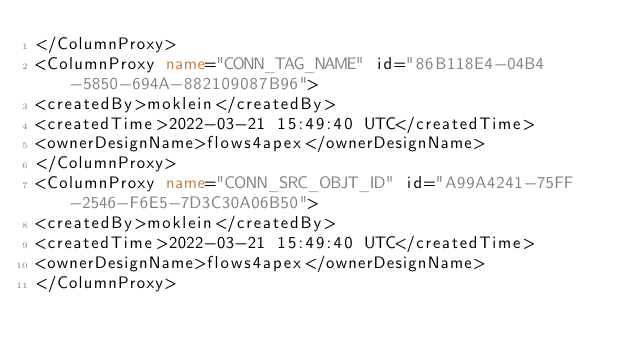Convert code to text. <code><loc_0><loc_0><loc_500><loc_500><_XML_></ColumnProxy>
<ColumnProxy name="CONN_TAG_NAME" id="86B118E4-04B4-5850-694A-882109087B96">
<createdBy>moklein</createdBy>
<createdTime>2022-03-21 15:49:40 UTC</createdTime>
<ownerDesignName>flows4apex</ownerDesignName>
</ColumnProxy>
<ColumnProxy name="CONN_SRC_OBJT_ID" id="A99A4241-75FF-2546-F6E5-7D3C30A06B50">
<createdBy>moklein</createdBy>
<createdTime>2022-03-21 15:49:40 UTC</createdTime>
<ownerDesignName>flows4apex</ownerDesignName>
</ColumnProxy></code> 